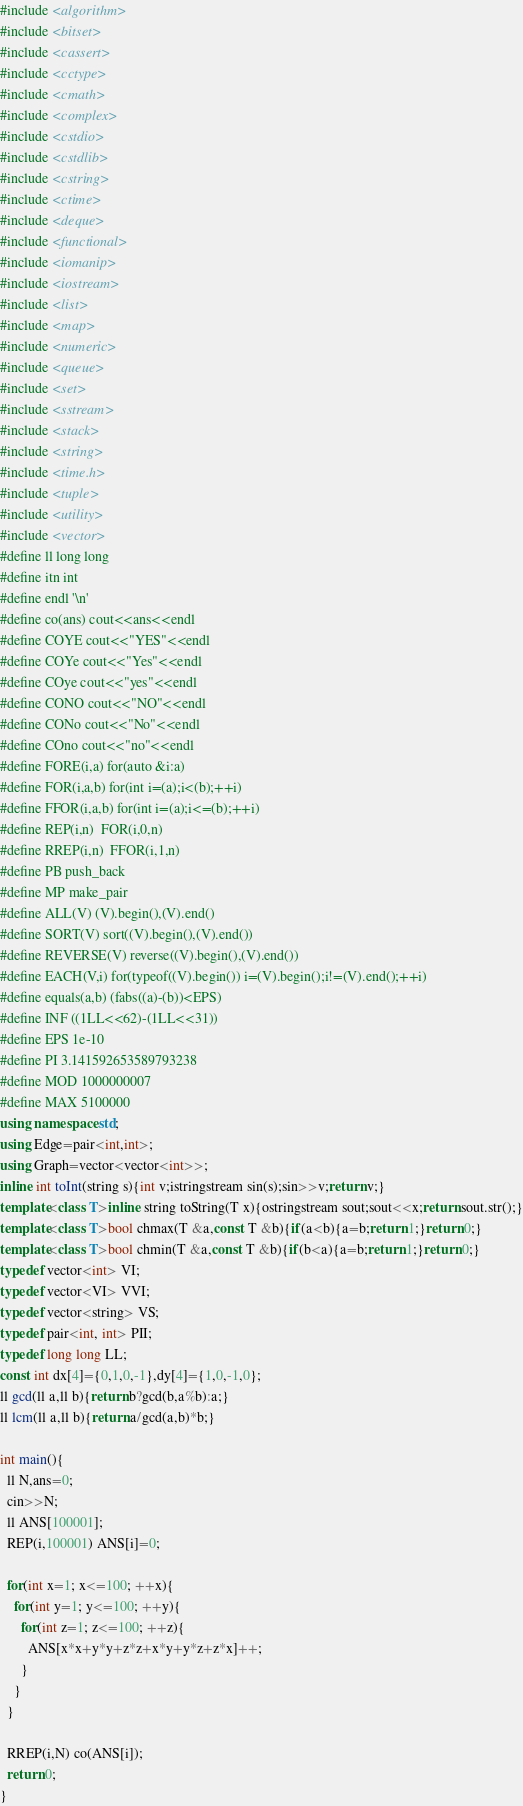<code> <loc_0><loc_0><loc_500><loc_500><_C++_>#include <algorithm>
#include <bitset>
#include <cassert>
#include <cctype>
#include <cmath>
#include <complex>
#include <cstdio>
#include <cstdlib>
#include <cstring>
#include <ctime>
#include <deque>
#include <functional>
#include <iomanip>
#include <iostream>
#include <list>
#include <map>
#include <numeric>
#include <queue>
#include <set>
#include <sstream>
#include <stack>
#include <string>
#include <time.h>
#include <tuple>
#include <utility>
#include <vector>
#define ll long long
#define itn int
#define endl '\n'
#define co(ans) cout<<ans<<endl
#define COYE cout<<"YES"<<endl
#define COYe cout<<"Yes"<<endl
#define COye cout<<"yes"<<endl
#define CONO cout<<"NO"<<endl
#define CONo cout<<"No"<<endl
#define COno cout<<"no"<<endl
#define FORE(i,a) for(auto &i:a)
#define FOR(i,a,b) for(int i=(a);i<(b);++i)
#define FFOR(i,a,b) for(int i=(a);i<=(b);++i)
#define REP(i,n)  FOR(i,0,n)
#define RREP(i,n)  FFOR(i,1,n)
#define PB push_back
#define MP make_pair
#define ALL(V) (V).begin(),(V).end()
#define SORT(V) sort((V).begin(),(V).end())
#define REVERSE(V) reverse((V).begin(),(V).end())
#define EACH(V,i) for(typeof((V).begin()) i=(V).begin();i!=(V).end();++i)
#define equals(a,b) (fabs((a)-(b))<EPS)
#define INF ((1LL<<62)-(1LL<<31))
#define EPS 1e-10
#define PI 3.141592653589793238
#define MOD 1000000007
#define MAX 5100000
using namespace std;
using Edge=pair<int,int>;
using Graph=vector<vector<int>>;
inline int toInt(string s){int v;istringstream sin(s);sin>>v;return v;}
template<class T>inline string toString(T x){ostringstream sout;sout<<x;return sout.str();}
template<class T>bool chmax(T &a,const T &b){if(a<b){a=b;return 1;}return 0;}
template<class T>bool chmin(T &a,const T &b){if(b<a){a=b;return 1;}return 0;}
typedef vector<int> VI;
typedef vector<VI> VVI;
typedef vector<string> VS;
typedef pair<int, int> PII;
typedef long long LL;
const int dx[4]={0,1,0,-1},dy[4]={1,0,-1,0};
ll gcd(ll a,ll b){return b?gcd(b,a%b):a;}
ll lcm(ll a,ll b){return a/gcd(a,b)*b;}

int main(){
  ll N,ans=0;
  cin>>N;
  ll ANS[100001];
  REP(i,100001) ANS[i]=0;
  
  for(int x=1; x<=100; ++x){
    for(int y=1; y<=100; ++y){
      for(int z=1; z<=100; ++z){
        ANS[x*x+y*y+z*z+x*y+y*z+z*x]++;
      }
    }
  }  
  
  RREP(i,N) co(ANS[i]);
  return 0;
}</code> 